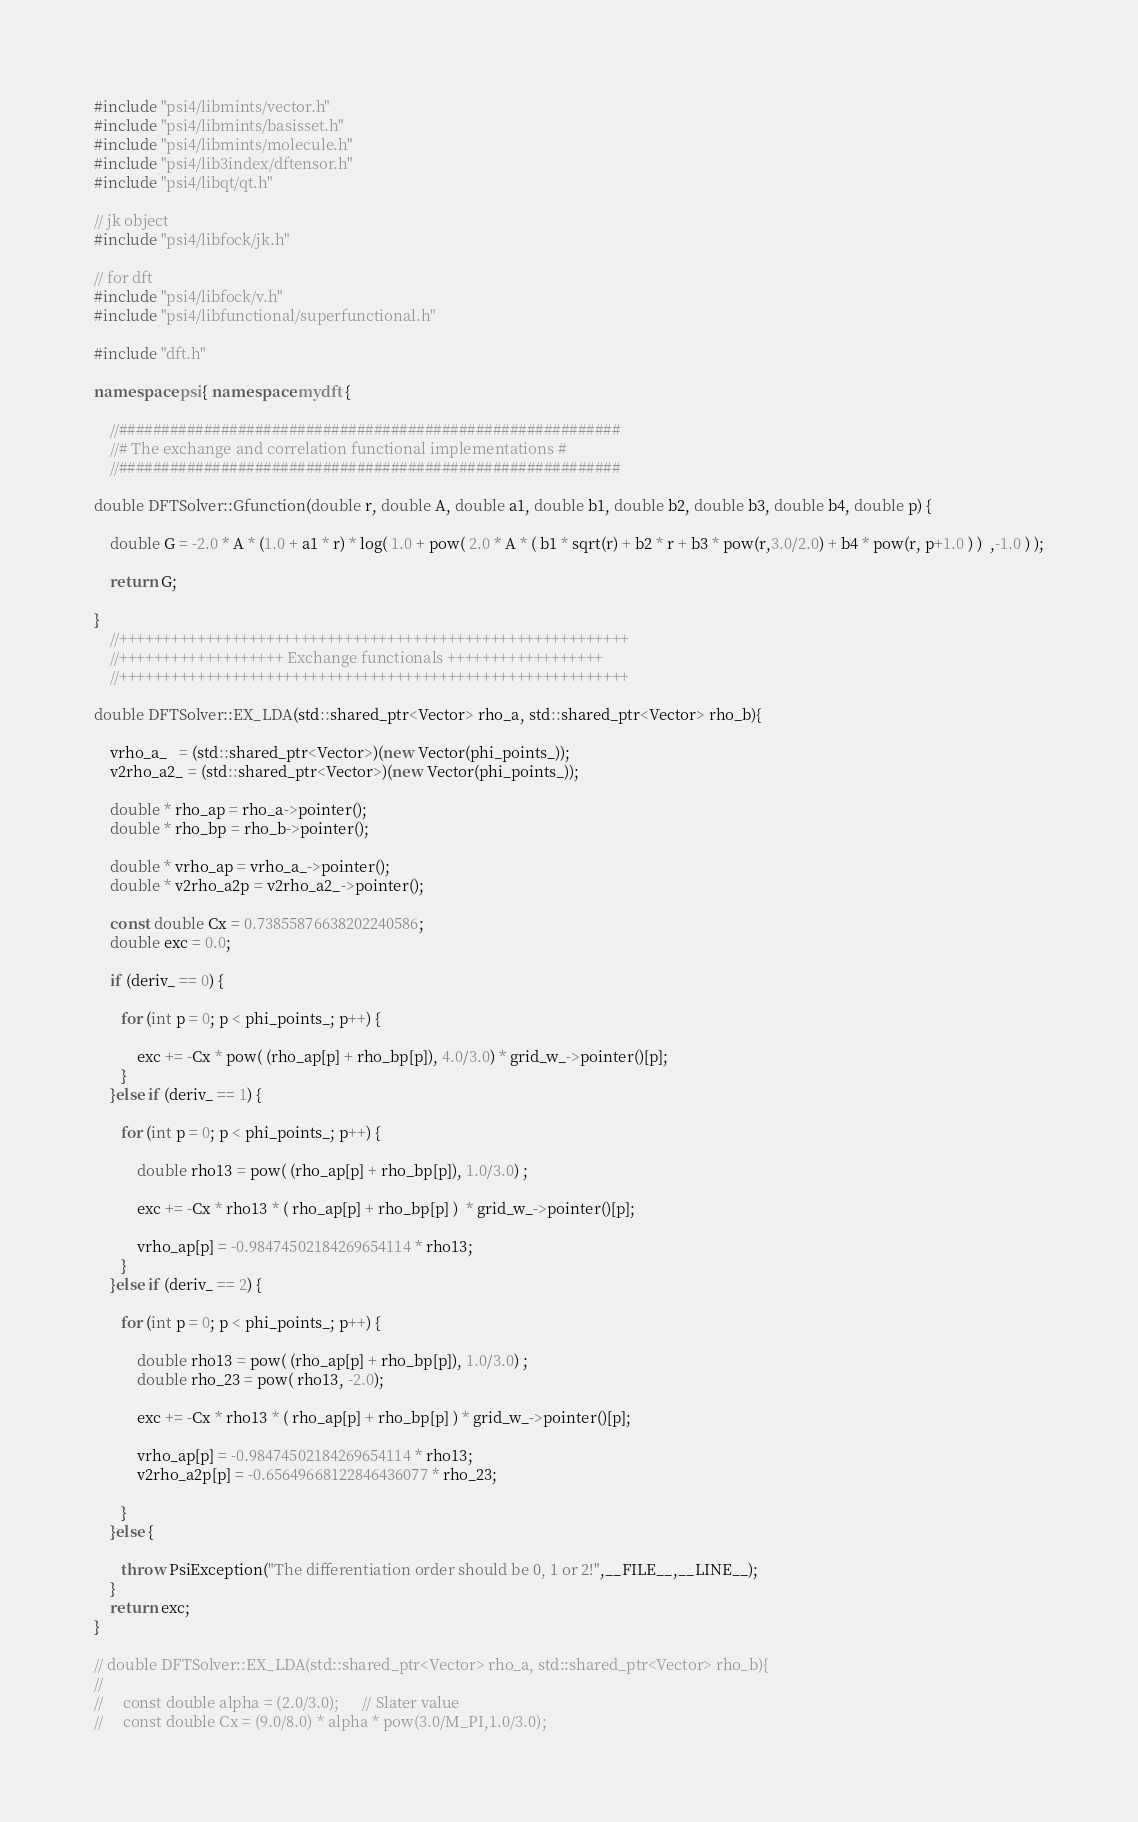Convert code to text. <code><loc_0><loc_0><loc_500><loc_500><_C++_>#include "psi4/libmints/vector.h"
#include "psi4/libmints/basisset.h"
#include "psi4/libmints/molecule.h"
#include "psi4/lib3index/dftensor.h"
#include "psi4/libqt/qt.h"

// jk object
#include "psi4/libfock/jk.h"

// for dft
#include "psi4/libfock/v.h"
#include "psi4/libfunctional/superfunctional.h"

#include "dft.h"

namespace psi{ namespace mydft {

    //###########################################################
    //# The exchange and correlation functional implementations #
    //###########################################################

double DFTSolver::Gfunction(double r, double A, double a1, double b1, double b2, double b3, double b4, double p) {

    double G = -2.0 * A * (1.0 + a1 * r) * log( 1.0 + pow( 2.0 * A * ( b1 * sqrt(r) + b2 * r + b3 * pow(r,3.0/2.0) + b4 * pow(r, p+1.0 ) )  ,-1.0 ) );

    return G;

}
    //+++++++++++++++++++++++++++++++++++++++++++++++++++++++++++
    //+++++++++++++++++++ Exchange functionals ++++++++++++++++++
    //+++++++++++++++++++++++++++++++++++++++++++++++++++++++++++

double DFTSolver::EX_LDA(std::shared_ptr<Vector> rho_a, std::shared_ptr<Vector> rho_b){

    vrho_a_   = (std::shared_ptr<Vector>)(new Vector(phi_points_));
    v2rho_a2_ = (std::shared_ptr<Vector>)(new Vector(phi_points_));

    double * rho_ap = rho_a->pointer();
    double * rho_bp = rho_b->pointer();

    double * vrho_ap = vrho_a_->pointer();
    double * v2rho_a2p = v2rho_a2_->pointer();

    const double Cx = 0.73855876638202240586;
    double exc = 0.0;

    if (deriv_ == 0) {

       for (int p = 0; p < phi_points_; p++) {

           exc += -Cx * pow( (rho_ap[p] + rho_bp[p]), 4.0/3.0) * grid_w_->pointer()[p];
       }
    }else if (deriv_ == 1) {

       for (int p = 0; p < phi_points_; p++) {

           double rho13 = pow( (rho_ap[p] + rho_bp[p]), 1.0/3.0) ;

           exc += -Cx * rho13 * ( rho_ap[p] + rho_bp[p] )  * grid_w_->pointer()[p];

           vrho_ap[p] = -0.98474502184269654114 * rho13;
       }
    }else if (deriv_ == 2) {

       for (int p = 0; p < phi_points_; p++) {

           double rho13 = pow( (rho_ap[p] + rho_bp[p]), 1.0/3.0) ;
           double rho_23 = pow( rho13, -2.0);

           exc += -Cx * rho13 * ( rho_ap[p] + rho_bp[p] ) * grid_w_->pointer()[p];

           vrho_ap[p] = -0.98474502184269654114 * rho13;
           v2rho_a2p[p] = -0.65649668122846436077 * rho_23;

       }
    }else {

       throw PsiException("The differentiation order should be 0, 1 or 2!",__FILE__,__LINE__);
    }
    return exc;
}

// double DFTSolver::EX_LDA(std::shared_ptr<Vector> rho_a, std::shared_ptr<Vector> rho_b){
//     
//     const double alpha = (2.0/3.0);      // Slater value
//     const double Cx = (9.0/8.0) * alpha * pow(3.0/M_PI,1.0/3.0);</code> 